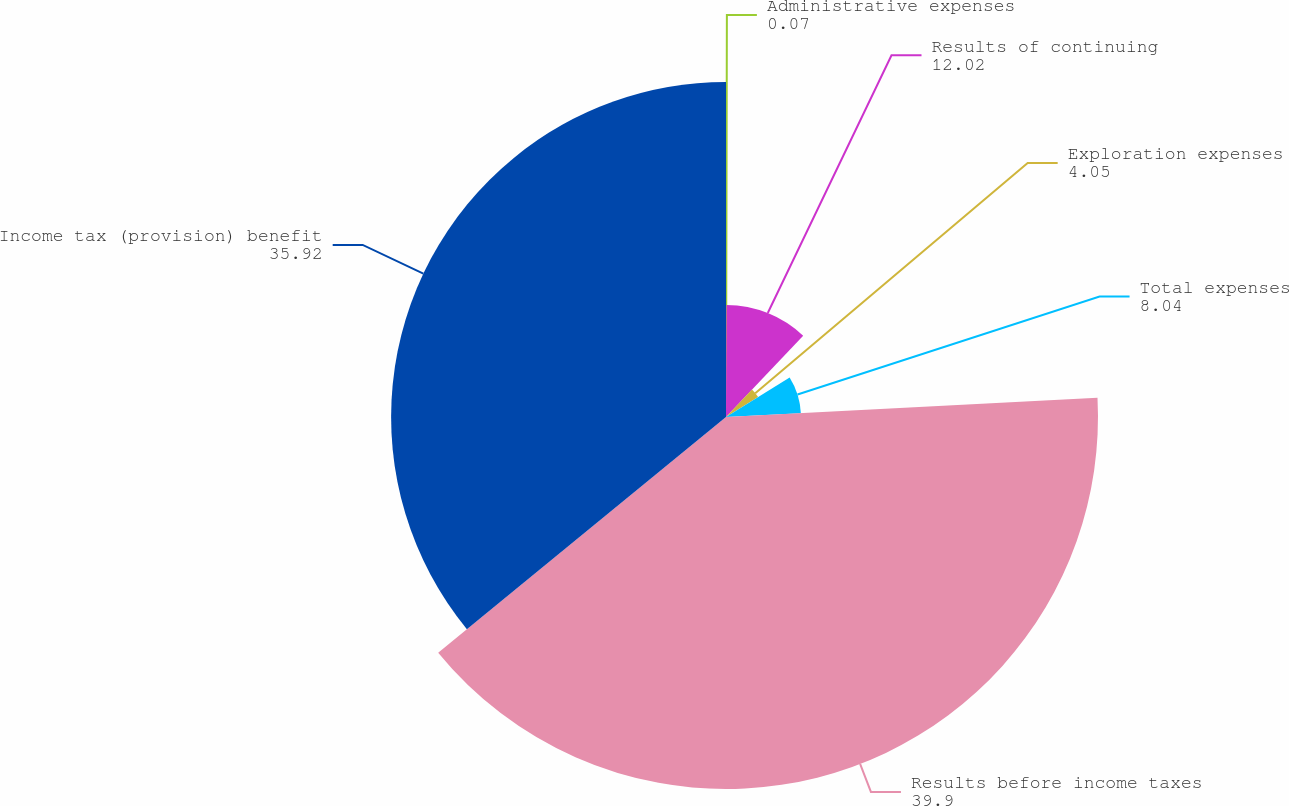Convert chart to OTSL. <chart><loc_0><loc_0><loc_500><loc_500><pie_chart><fcel>Administrative expenses<fcel>Results of continuing<fcel>Exploration expenses<fcel>Total expenses<fcel>Results before income taxes<fcel>Income tax (provision) benefit<nl><fcel>0.07%<fcel>12.02%<fcel>4.05%<fcel>8.04%<fcel>39.9%<fcel>35.92%<nl></chart> 